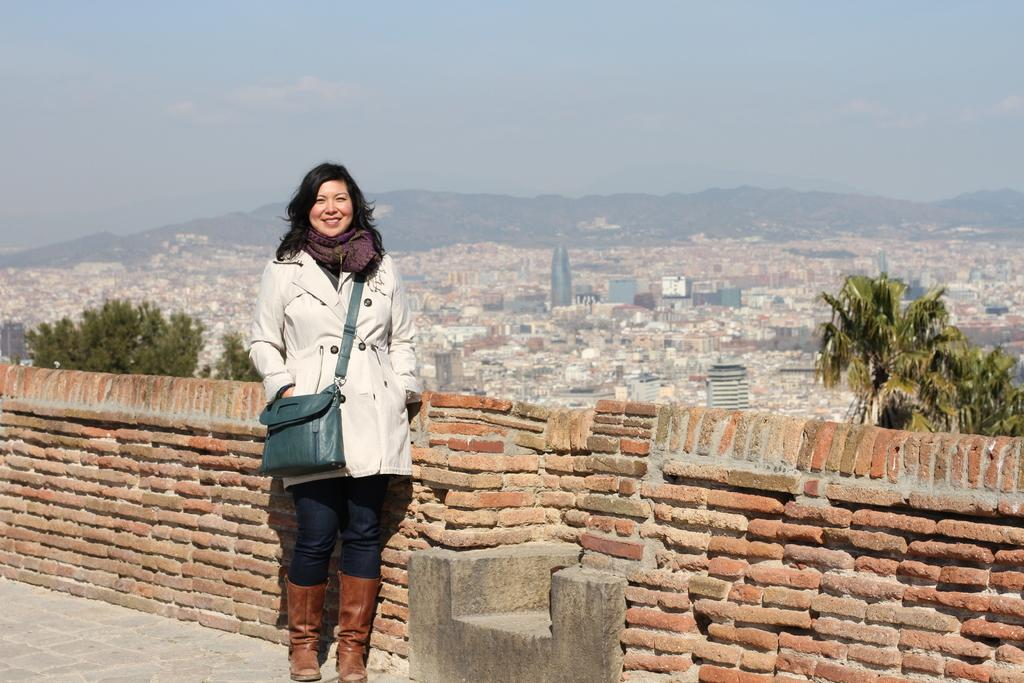Who is present in the image? There is a woman in the image. What is the woman doing in the image? The woman is standing in the image. What is the woman wearing on her shoulder? The woman is wearing a bag on her shoulder. What expression does the woman have in the image? The woman is smiling in the image. What can be seen in the background of the image? There is a wall, a city, hills, and the sky visible in the background. Can you see an airplane flying over the sea in the image? There is no airplane or sea present in the image. What type of harmony is being played by the woman in the image? The image does not depict any musical instruments or the act of playing music, so it is not possible to determine if any harmony is being played. 